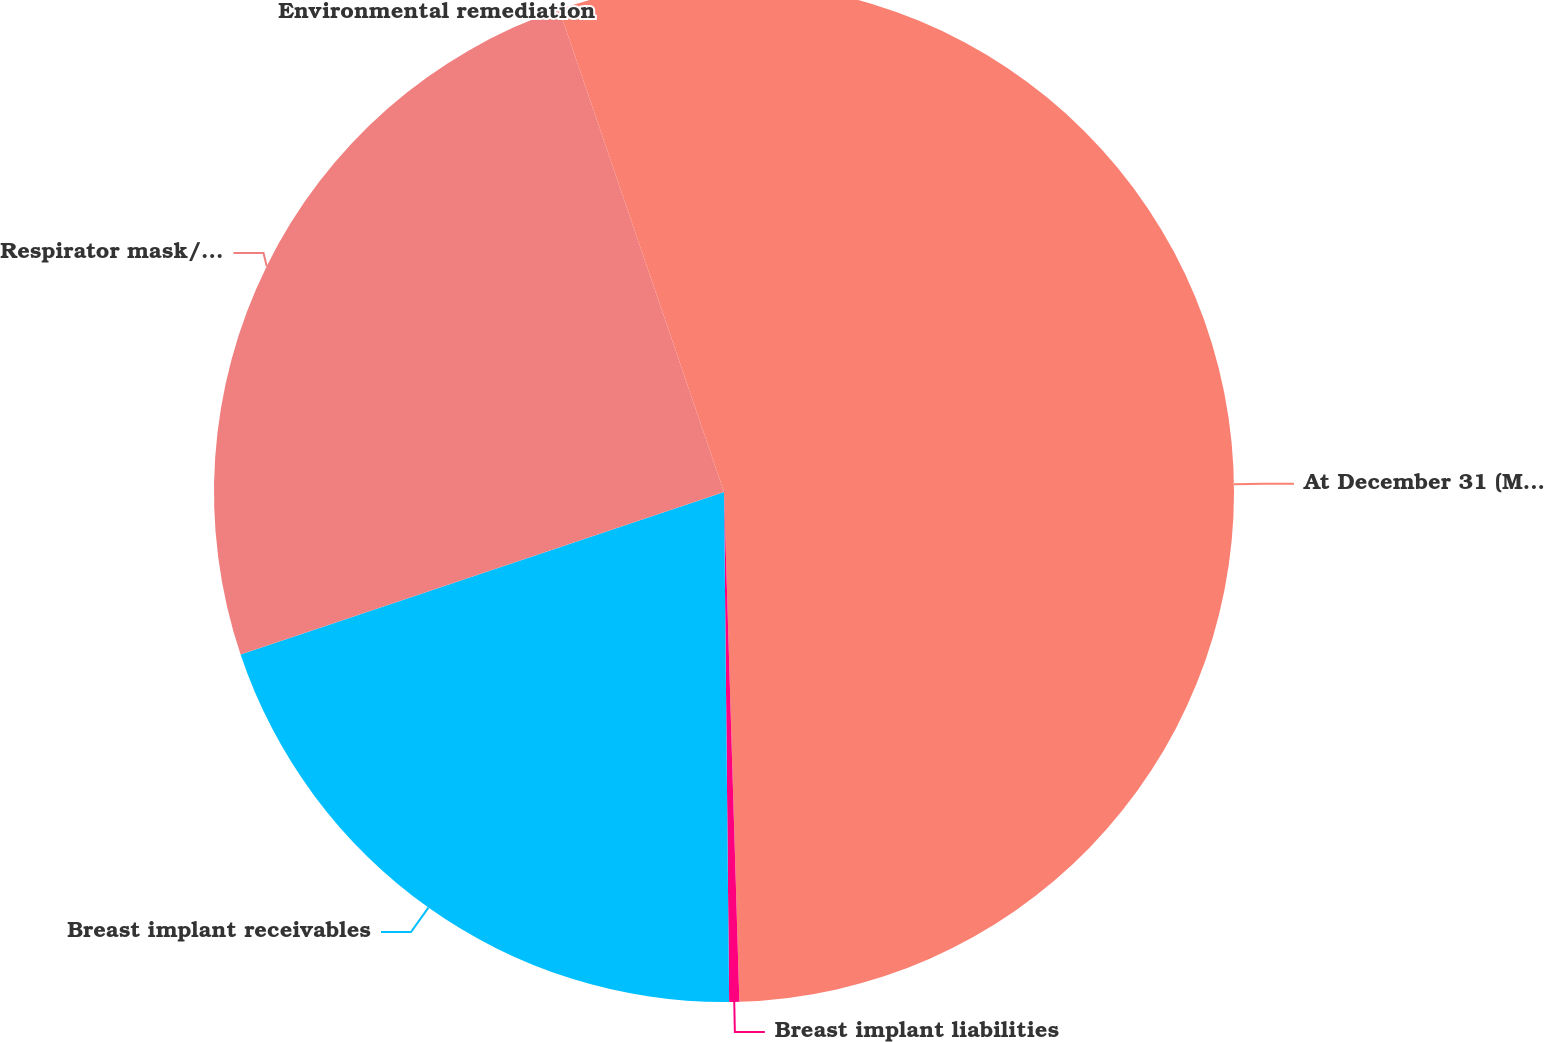Convert chart to OTSL. <chart><loc_0><loc_0><loc_500><loc_500><pie_chart><fcel>At December 31 (Millions)<fcel>Breast implant liabilities<fcel>Breast implant receivables<fcel>Respirator mask/asbestos<fcel>Environmental remediation<nl><fcel>49.52%<fcel>0.32%<fcel>20.0%<fcel>24.92%<fcel>5.24%<nl></chart> 